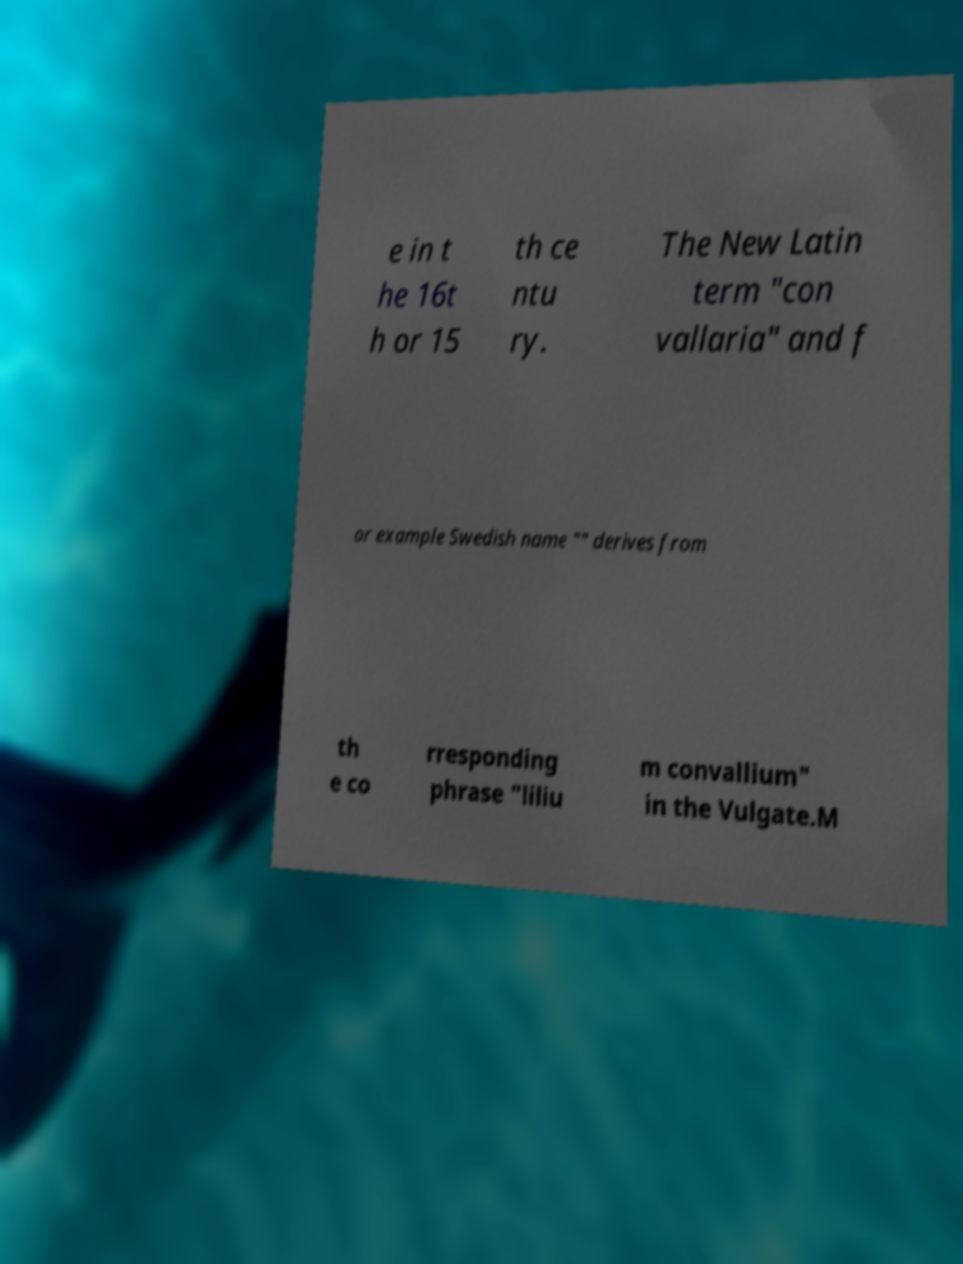There's text embedded in this image that I need extracted. Can you transcribe it verbatim? e in t he 16t h or 15 th ce ntu ry. The New Latin term "con vallaria" and f or example Swedish name "" derives from th e co rresponding phrase "liliu m convallium" in the Vulgate.M 